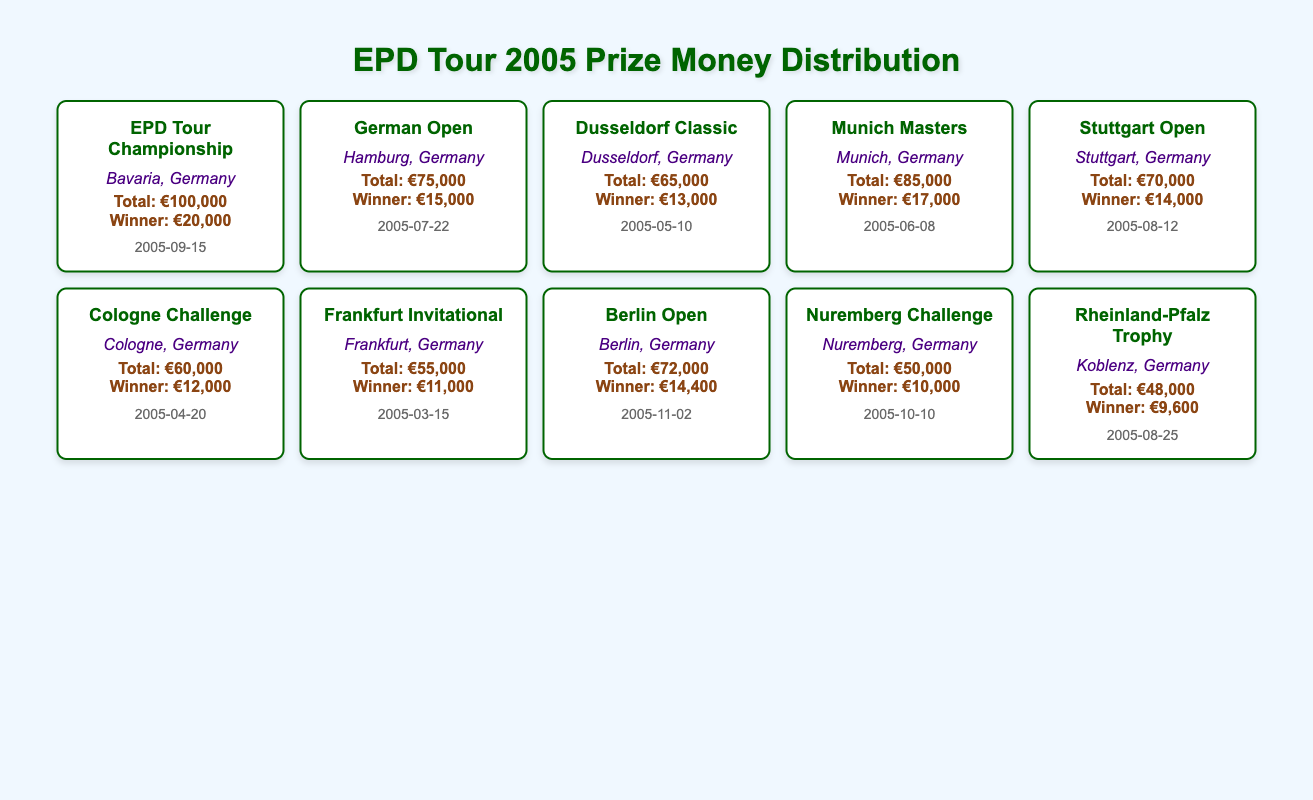What is the total prize money for the EPD Tour Championship? The table lists the total prize money for each event. For the EPD Tour Championship, the total prize money is explicitly stated as €100,000.
Answer: 100000 Which event offered the least total prize money in 2005? By reviewing the total prize money column, the Nuremberg Challenge has the lowest total at €50,000, compared to other events listed.
Answer: Nuremberg Challenge What is the prize money difference between the German Open and the Munich Masters? The total prize money for the German Open is €75,000 and for the Munich Masters is €85,000. The difference is calculated as €85,000 - €75,000 = €10,000.
Answer: 10000 Did the Berlin Open have a total prize money greater than the Stuttgart Open? The Berlin Open has total prize money of €72,000 while the Stuttgart Open has €70,000. Thus, the Berlin Open does have more total prize money.
Answer: Yes What is the average winner prize money across all events listed? To find the average winner prize money, first sum all winner prizes: €20,000 + €15,000 + €13,000 + €17,000 + €14,000 + €12,000 + €11,000 + €14,400 + €10,000 + €9,600 = € 156,000. Since there are 10 events, the average is €156,000 / 10 = €15,600.
Answer: 15600 Which event located in Berlin had a higher prize fund than Cologne Challenge? The Berlin Open total prize money is €72,000, while the Cologne Challenge is €60,000. Since €72,000 is greater than €60,000, the Berlin Open has a higher prize fund.
Answer: Berlin Open What was the winning prize for the Dusseldorf Classic? The winner prize money specifically for the Dusseldorf Classic is provided in the table as €13,000.
Answer: 13000 How many events had a total prize money of over €70,000? The events with total prize money over €70,000 include: EPD Tour Championship (€100,000), Munich Masters (€85,000), German Open (€75,000), and Berlin Open (€72,000). Thus, there are four events that meet this criterion.
Answer: 4 